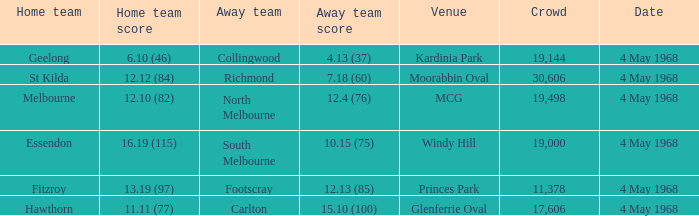What home team played at MCG? North Melbourne. 